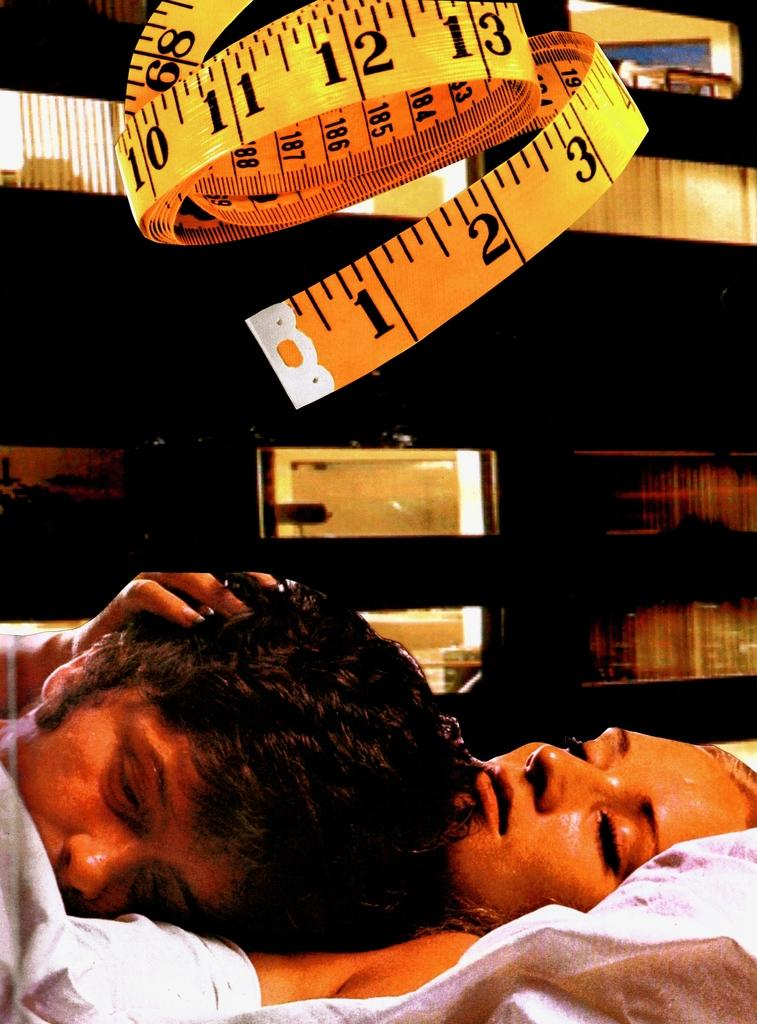What is the main subject of the image? The main subject of the image is a man. What is the man doing in the image? The man is lying on a lady in the image. Can you describe any additional objects or features in the image? There is a tape visible at the top of the image. Reasoning: Let's think step by step by step in order to produce the conversation. We start by identifying the main subject of the image, which is the man. Then, we describe the action he is performing, which is lying on a lady. Finally, we mention the presence of the tape, which is an additional object in the image. We avoid asking yes/no questions and ensure that the language is simple and clear. Absurd Question/Answer: What type of discovery was made by the man in the image? There is no indication of a discovery in the image; the man is simply lying on a lady. How does the friction between the man and the lady affect the image? The image does not provide any information about friction between the man and the lady, so we cannot determine its effect. 